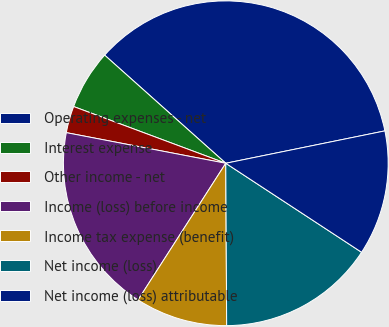<chart> <loc_0><loc_0><loc_500><loc_500><pie_chart><fcel>Operating expenses - net<fcel>Interest expense<fcel>Other income - net<fcel>Income (loss) before income<fcel>Income tax expense (benefit)<fcel>Net income (loss)<fcel>Net income (loss) attributable<nl><fcel>35.21%<fcel>5.92%<fcel>2.66%<fcel>18.94%<fcel>9.17%<fcel>15.68%<fcel>12.43%<nl></chart> 